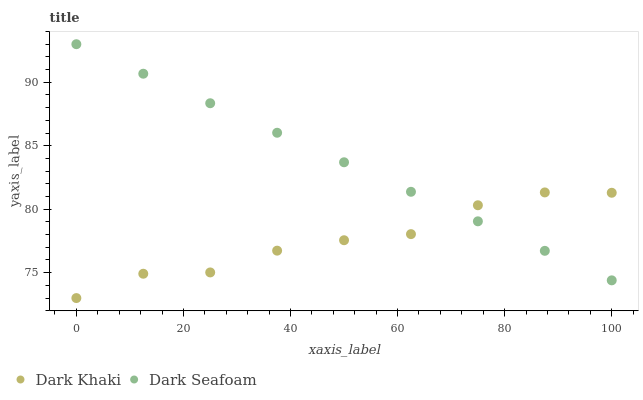Does Dark Khaki have the minimum area under the curve?
Answer yes or no. Yes. Does Dark Seafoam have the maximum area under the curve?
Answer yes or no. Yes. Does Dark Seafoam have the minimum area under the curve?
Answer yes or no. No. Is Dark Seafoam the smoothest?
Answer yes or no. Yes. Is Dark Khaki the roughest?
Answer yes or no. Yes. Is Dark Seafoam the roughest?
Answer yes or no. No. Does Dark Khaki have the lowest value?
Answer yes or no. Yes. Does Dark Seafoam have the lowest value?
Answer yes or no. No. Does Dark Seafoam have the highest value?
Answer yes or no. Yes. Does Dark Seafoam intersect Dark Khaki?
Answer yes or no. Yes. Is Dark Seafoam less than Dark Khaki?
Answer yes or no. No. Is Dark Seafoam greater than Dark Khaki?
Answer yes or no. No. 